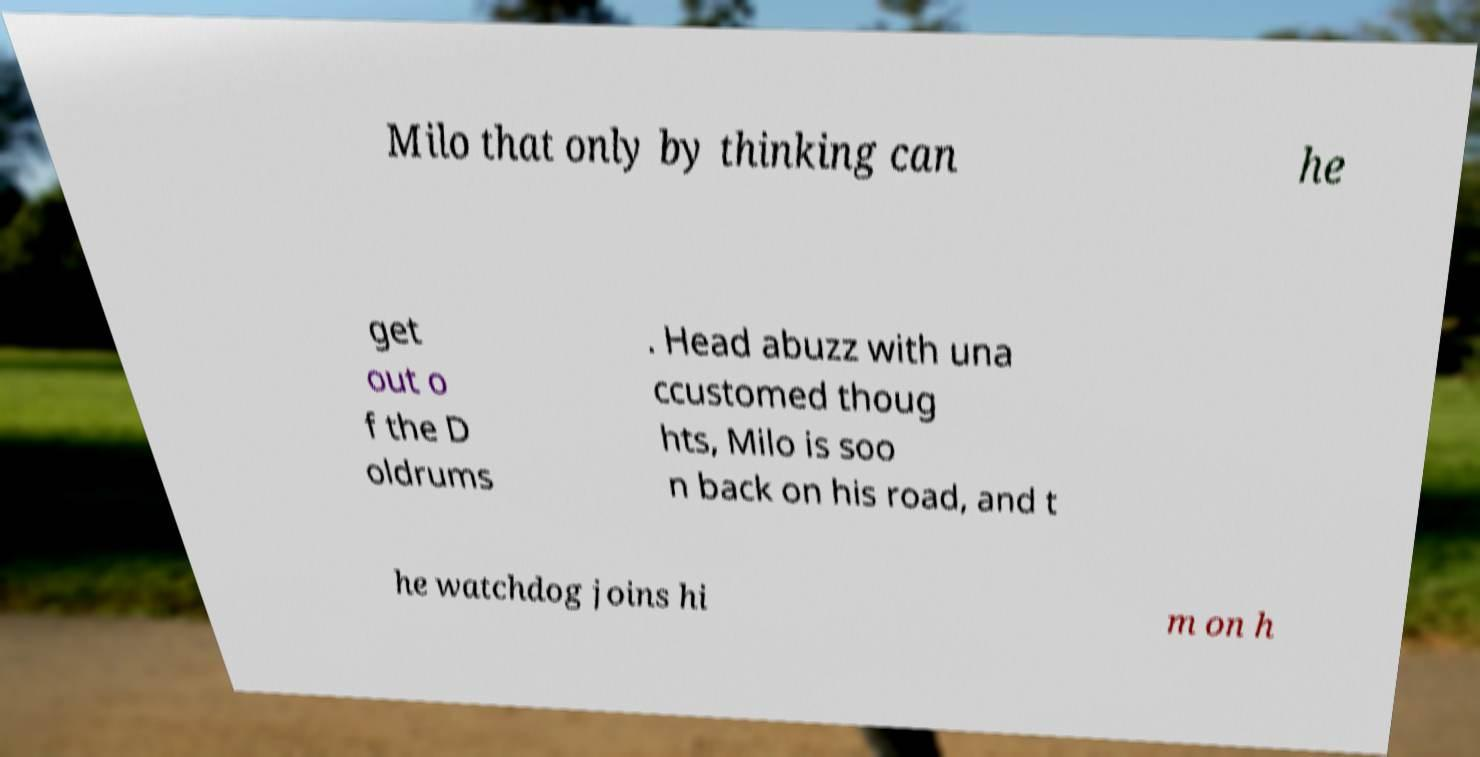Can you read and provide the text displayed in the image?This photo seems to have some interesting text. Can you extract and type it out for me? Milo that only by thinking can he get out o f the D oldrums . Head abuzz with una ccustomed thoug hts, Milo is soo n back on his road, and t he watchdog joins hi m on h 